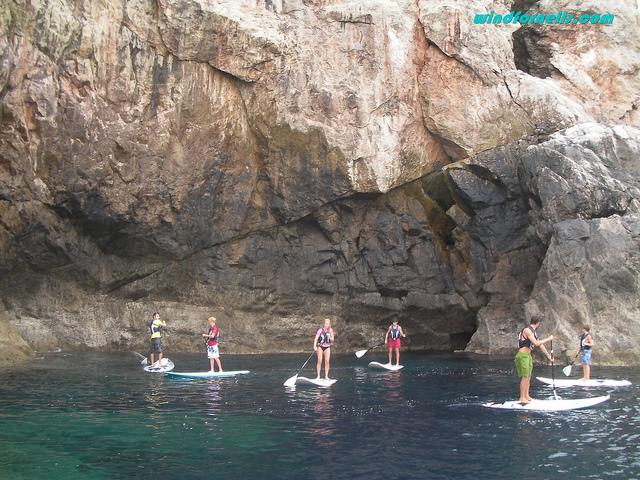Is everyone holding a paddle?
Quick response, please. Yes. What is in the background?
Be succinct. Rocks. How many people?
Short answer required. 6. What sport are these people doing?
Answer briefly. Paddle boarding. 